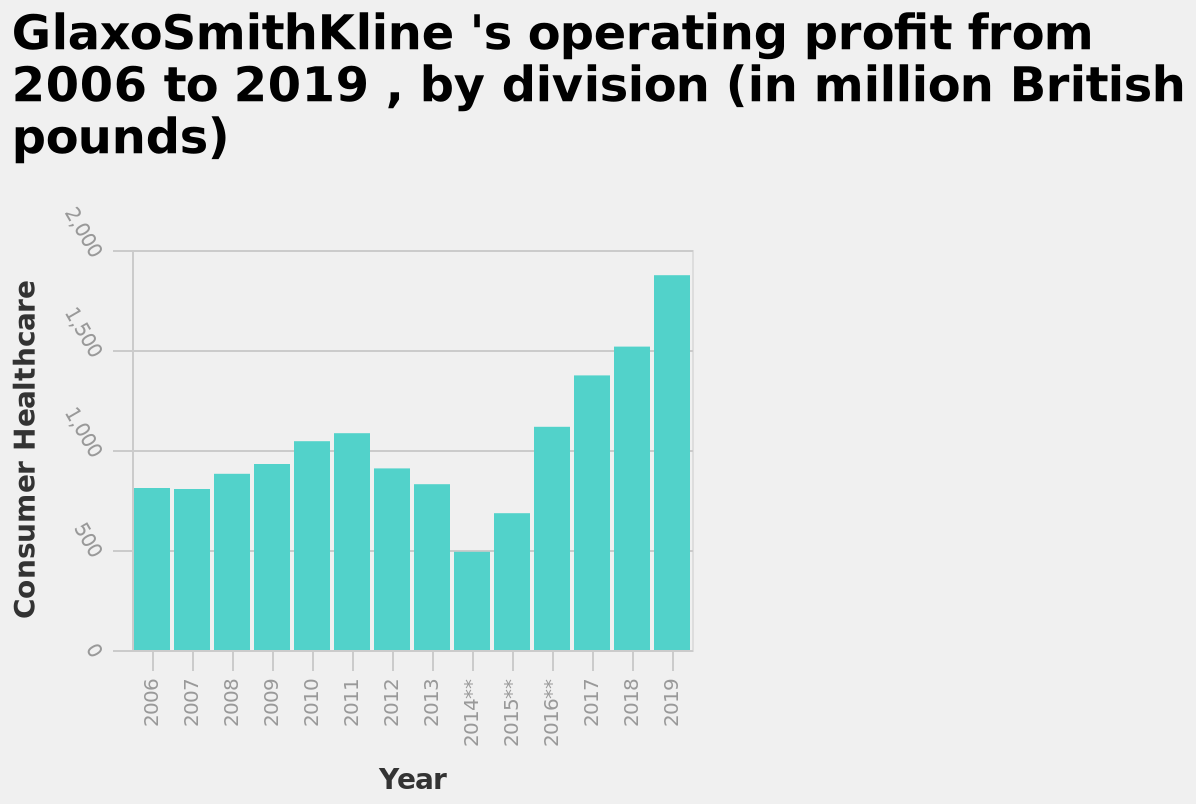<image>
What is the range of years covered in the bar chart? The bar chart covers the years 2006 to 2019. 